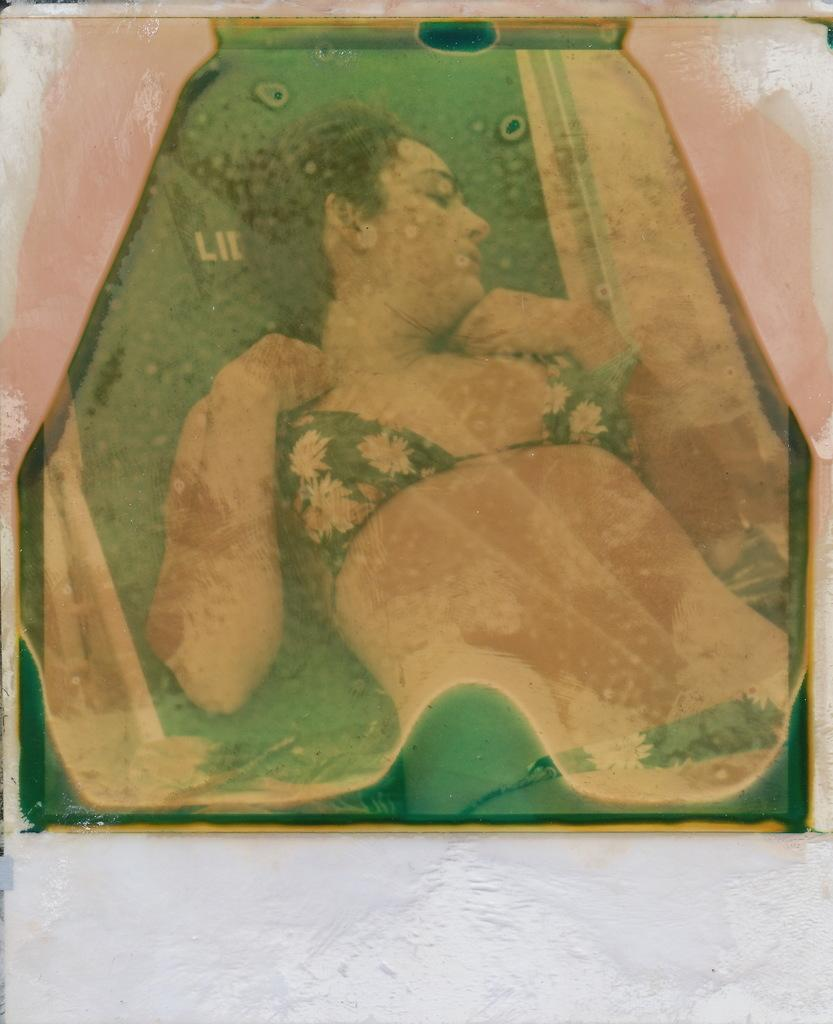What is attached to the wall in the image? There is a board attached to the wall in the image. What is on the board? The board appears to have a painting on it. What does the painting depict? The painting depicts a woman lying down. How many houses are visible in the painting on the board? There are no houses visible in the painting on the board; it depicts a woman lying down. What type of joke is being told by the woman in the painting? There is no indication of a joke being told in the painting; it depicts a woman lying down. 